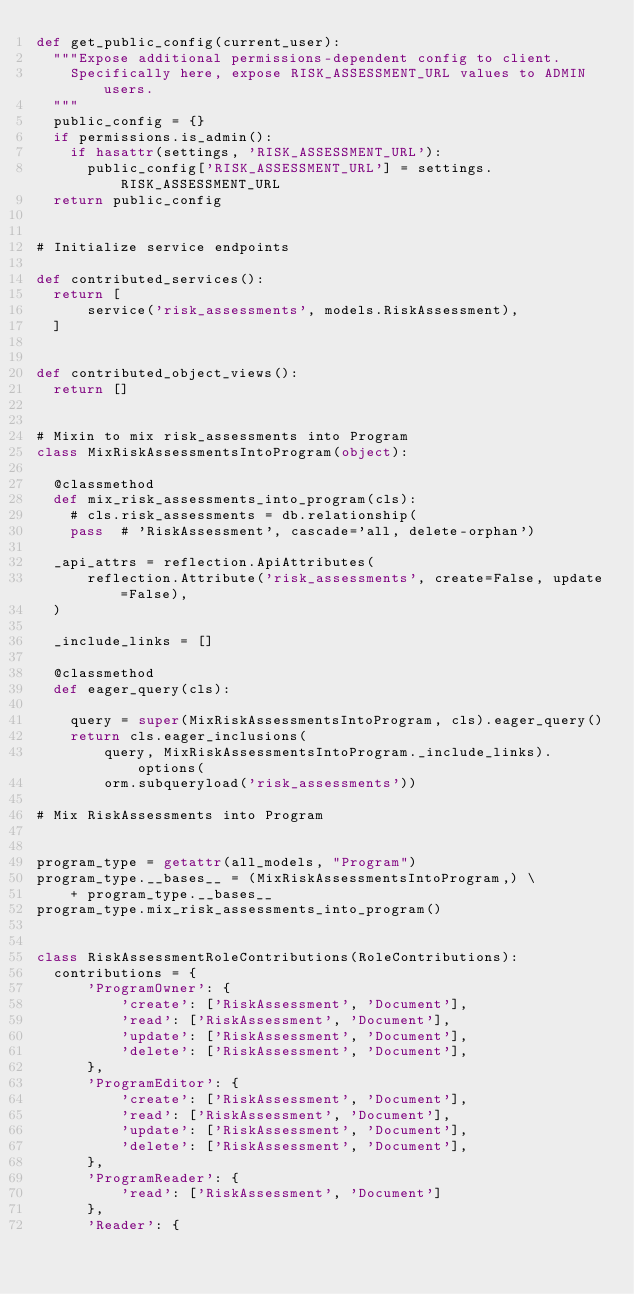<code> <loc_0><loc_0><loc_500><loc_500><_Python_>def get_public_config(current_user):
  """Expose additional permissions-dependent config to client.
    Specifically here, expose RISK_ASSESSMENT_URL values to ADMIN users.
  """
  public_config = {}
  if permissions.is_admin():
    if hasattr(settings, 'RISK_ASSESSMENT_URL'):
      public_config['RISK_ASSESSMENT_URL'] = settings.RISK_ASSESSMENT_URL
  return public_config


# Initialize service endpoints

def contributed_services():
  return [
      service('risk_assessments', models.RiskAssessment),
  ]


def contributed_object_views():
  return []


# Mixin to mix risk_assessments into Program
class MixRiskAssessmentsIntoProgram(object):

  @classmethod
  def mix_risk_assessments_into_program(cls):
    # cls.risk_assessments = db.relationship(
    pass  # 'RiskAssessment', cascade='all, delete-orphan')

  _api_attrs = reflection.ApiAttributes(
      reflection.Attribute('risk_assessments', create=False, update=False),
  )

  _include_links = []

  @classmethod
  def eager_query(cls):

    query = super(MixRiskAssessmentsIntoProgram, cls).eager_query()
    return cls.eager_inclusions(
        query, MixRiskAssessmentsIntoProgram._include_links).options(
        orm.subqueryload('risk_assessments'))

# Mix RiskAssessments into Program


program_type = getattr(all_models, "Program")
program_type.__bases__ = (MixRiskAssessmentsIntoProgram,) \
    + program_type.__bases__
program_type.mix_risk_assessments_into_program()


class RiskAssessmentRoleContributions(RoleContributions):
  contributions = {
      'ProgramOwner': {
          'create': ['RiskAssessment', 'Document'],
          'read': ['RiskAssessment', 'Document'],
          'update': ['RiskAssessment', 'Document'],
          'delete': ['RiskAssessment', 'Document'],
      },
      'ProgramEditor': {
          'create': ['RiskAssessment', 'Document'],
          'read': ['RiskAssessment', 'Document'],
          'update': ['RiskAssessment', 'Document'],
          'delete': ['RiskAssessment', 'Document'],
      },
      'ProgramReader': {
          'read': ['RiskAssessment', 'Document']
      },
      'Reader': {</code> 